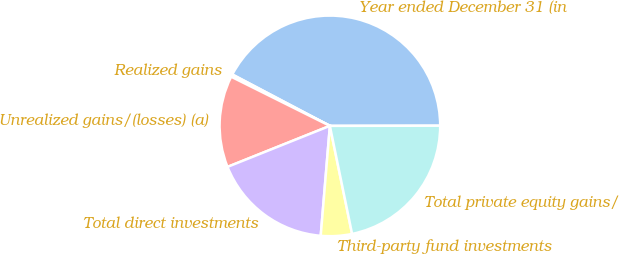<chart> <loc_0><loc_0><loc_500><loc_500><pie_chart><fcel>Year ended December 31 (in<fcel>Realized gains<fcel>Unrealized gains/(losses) (a)<fcel>Total direct investments<fcel>Third-party fund investments<fcel>Total private equity gains/<nl><fcel>42.26%<fcel>0.36%<fcel>13.42%<fcel>17.61%<fcel>4.55%<fcel>21.8%<nl></chart> 